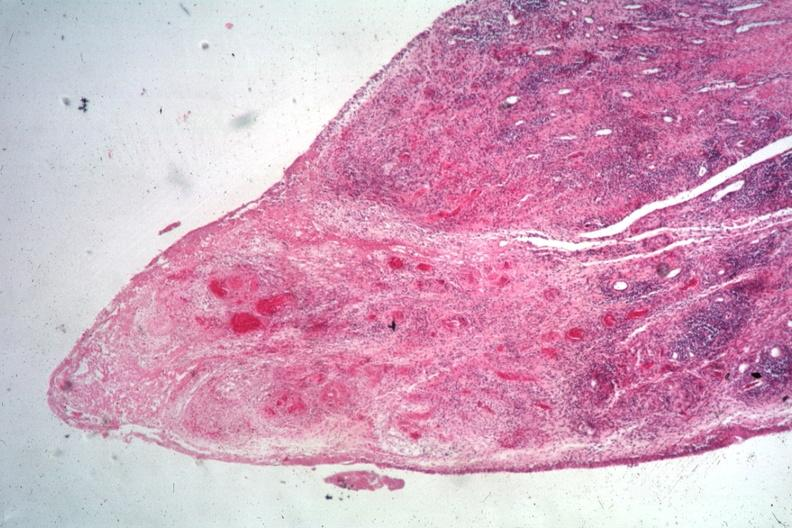what does this image show?
Answer the question using a single word or phrase. Typical lesion case associated with widespread vasculitis 